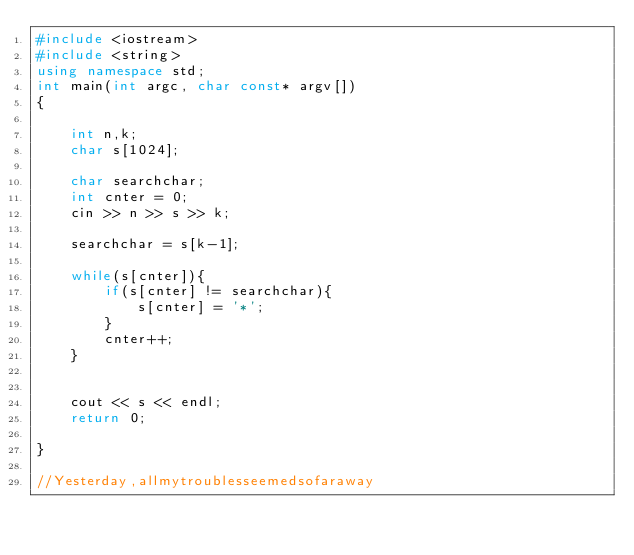<code> <loc_0><loc_0><loc_500><loc_500><_C++_>#include <iostream>
#include <string>
using namespace std;
int main(int argc, char const* argv[])
{

    int n,k;
    char s[1024];

    char searchchar;
    int cnter = 0;
    cin >> n >> s >> k;
    
    searchchar = s[k-1];

    while(s[cnter]){
        if(s[cnter] != searchchar){
            s[cnter] = '*';
        }
        cnter++;
    }

    
    cout << s << endl;
    return 0;

}

//Yesterday,allmytroublesseemedsofaraway</code> 